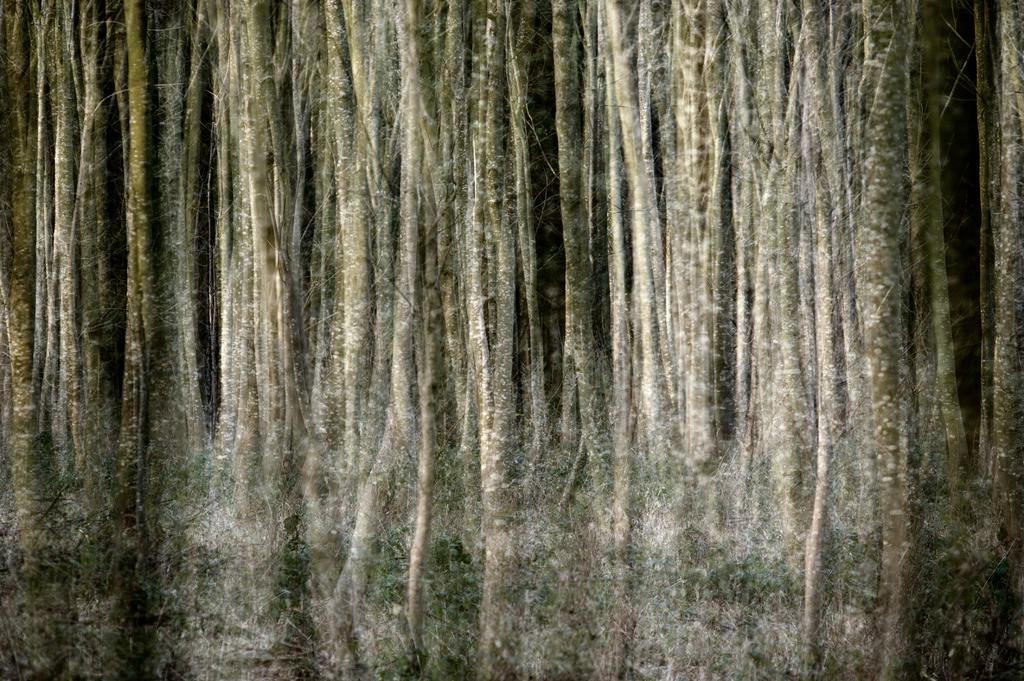What type of objects are present in the image? There are logs of trees in the image. Can you describe the appearance of the logs? The logs appear to be long and cylindrical, likely cut from tree trunks. What might be the purpose of these logs? The logs could be used for various purposes, such as firewood, construction, or furniture. What type of tooth can be seen in the image? There is no tooth present in the image; it features logs of trees. 